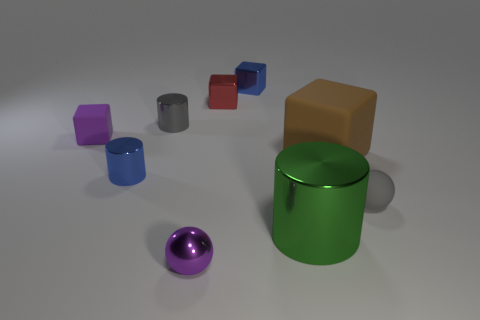Subtract all tiny cubes. How many cubes are left? 1 Add 1 brown cylinders. How many objects exist? 10 Subtract 3 cylinders. How many cylinders are left? 0 Subtract all cyan cylinders. Subtract all purple spheres. How many cylinders are left? 3 Subtract all gray blocks. How many gray balls are left? 1 Subtract all balls. Subtract all big green metal cylinders. How many objects are left? 6 Add 4 blue metallic things. How many blue metallic things are left? 6 Add 4 tiny blue blocks. How many tiny blue blocks exist? 5 Subtract all brown blocks. How many blocks are left? 3 Subtract 1 red cubes. How many objects are left? 8 